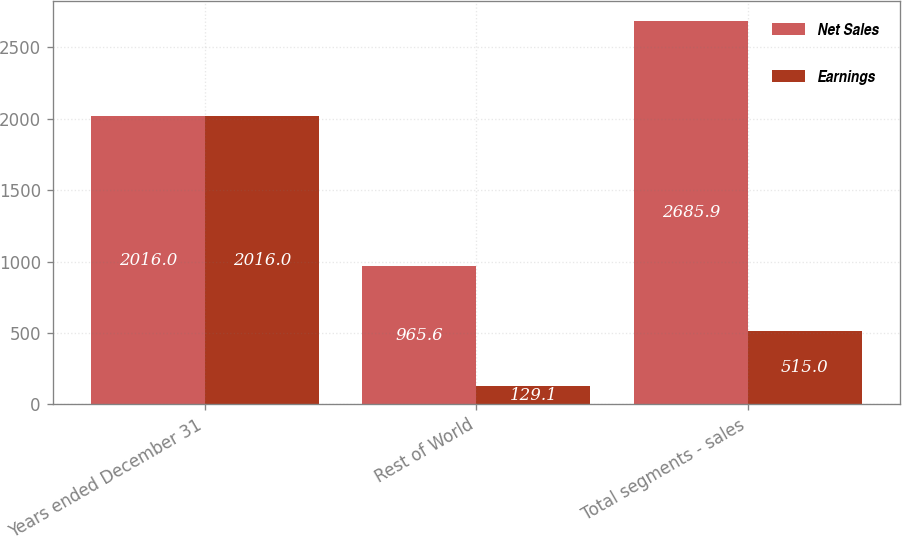Convert chart to OTSL. <chart><loc_0><loc_0><loc_500><loc_500><stacked_bar_chart><ecel><fcel>Years ended December 31<fcel>Rest of World<fcel>Total segments - sales<nl><fcel>Net Sales<fcel>2016<fcel>965.6<fcel>2685.9<nl><fcel>Earnings<fcel>2016<fcel>129.1<fcel>515<nl></chart> 